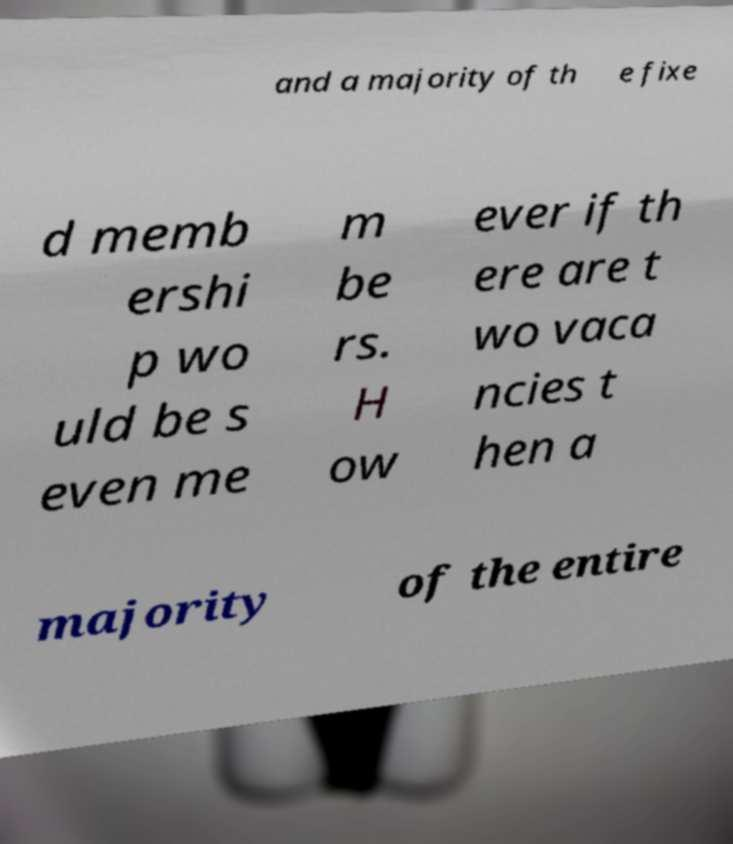Could you assist in decoding the text presented in this image and type it out clearly? and a majority of th e fixe d memb ershi p wo uld be s even me m be rs. H ow ever if th ere are t wo vaca ncies t hen a majority of the entire 